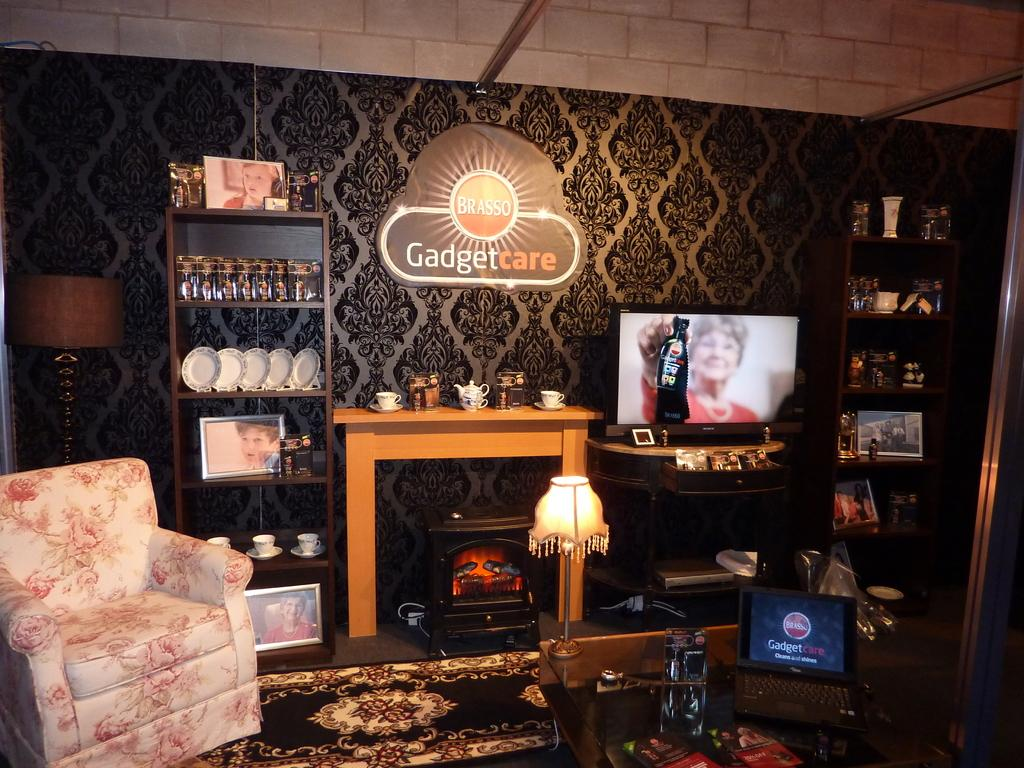What electronic device can be seen on the table in the image? There is a laptop on a table in the image. What type of lighting is present in the image? There are two lamps in the image. What type of entertainment device is visible in the image? There is a TV in the image. What type of household items can be seen in the image? There are crockery items in the image. What type of seating is present in the image? There is a sofa chair in the image. What is the setting of the image? The setting is in a living room. What type of fruit is hanging from the lamp in the image? There is no fruit hanging from the lamp in the image. Is there a crook present in the image? There is no crook present in the image. 